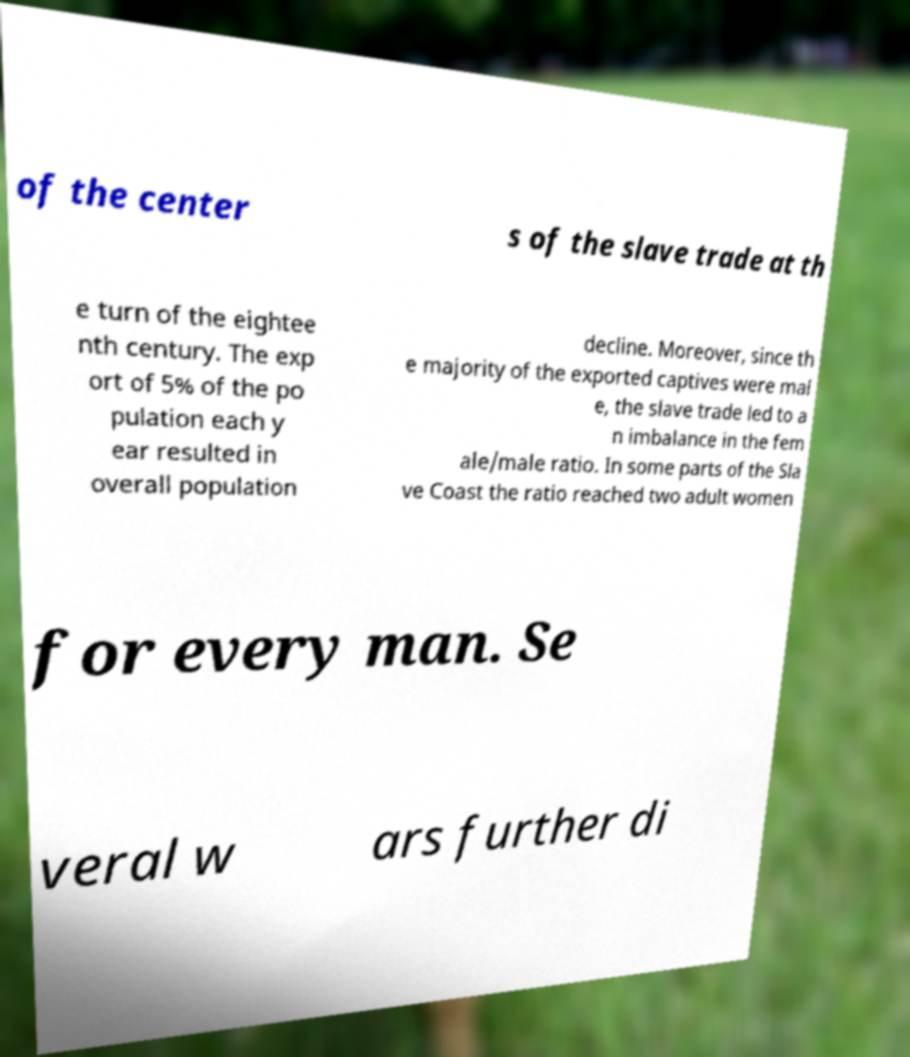I need the written content from this picture converted into text. Can you do that? of the center s of the slave trade at th e turn of the eightee nth century. The exp ort of 5% of the po pulation each y ear resulted in overall population decline. Moreover, since th e majority of the exported captives were mal e, the slave trade led to a n imbalance in the fem ale/male ratio. In some parts of the Sla ve Coast the ratio reached two adult women for every man. Se veral w ars further di 